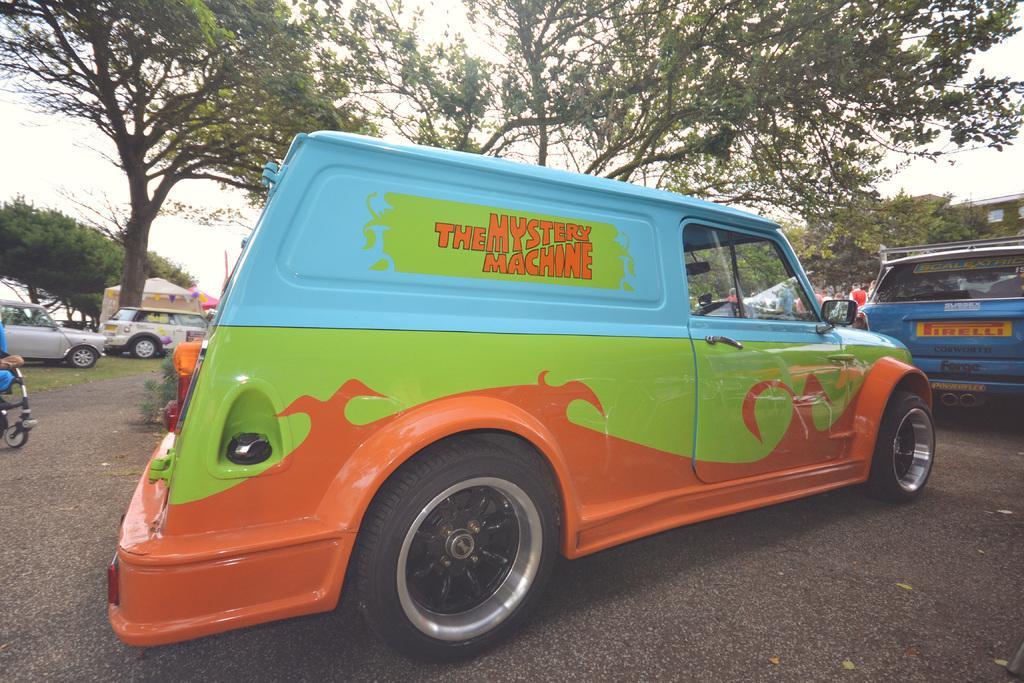Please provide a concise description of this image. In this image in front there are vehicles on the road. In the background of the image there are trees, stalls and sky. 